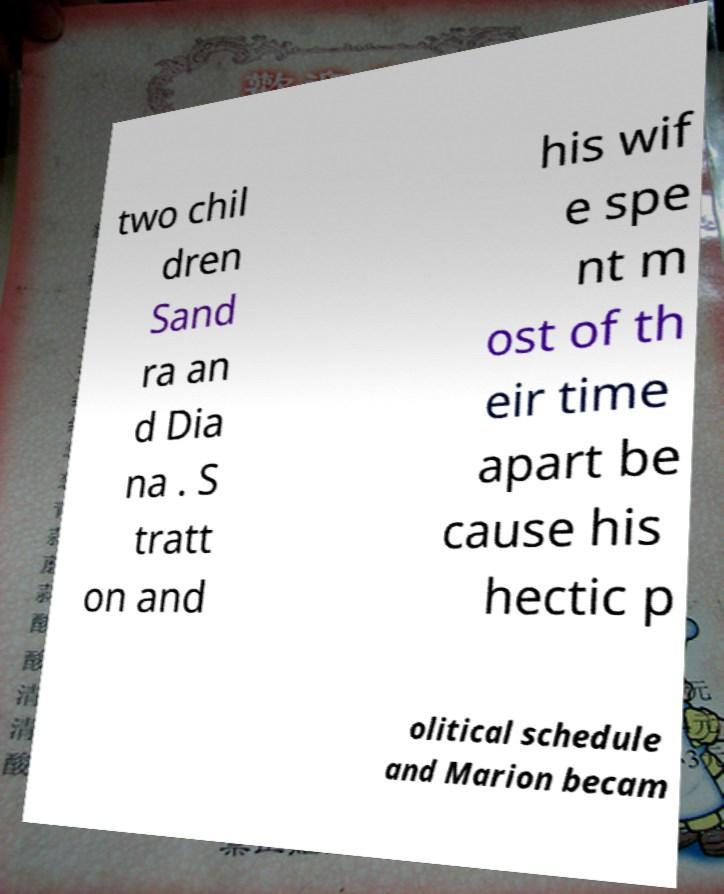Could you extract and type out the text from this image? two chil dren Sand ra an d Dia na . S tratt on and his wif e spe nt m ost of th eir time apart be cause his hectic p olitical schedule and Marion becam 